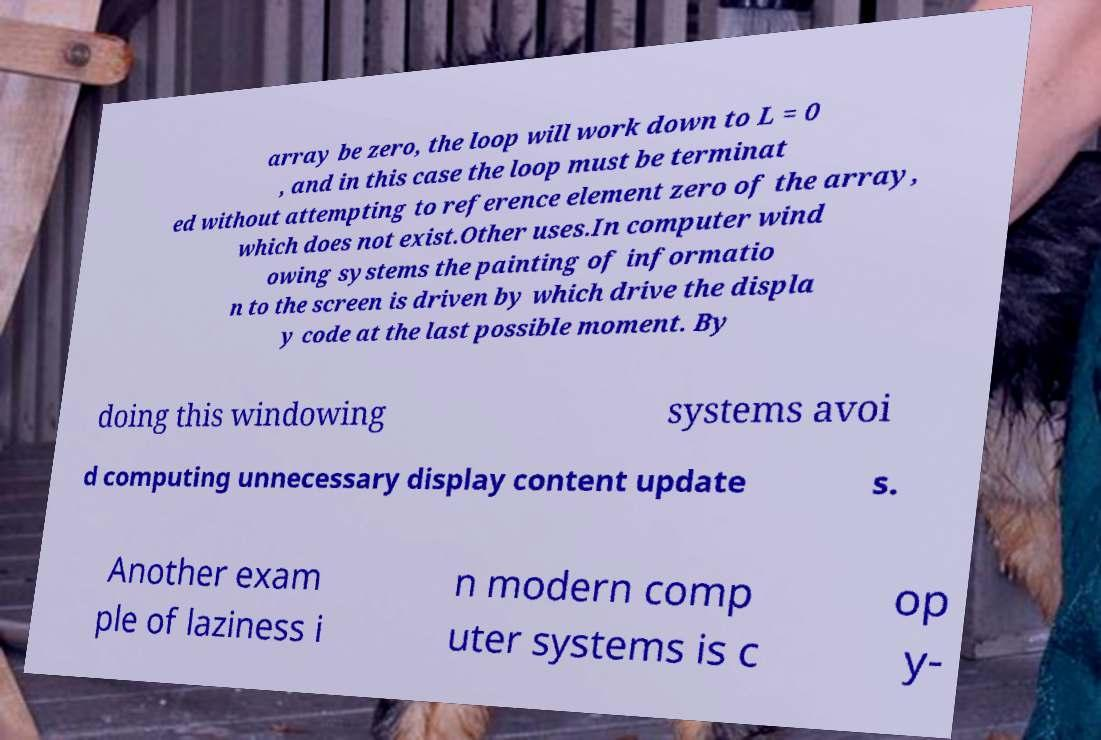I need the written content from this picture converted into text. Can you do that? array be zero, the loop will work down to L = 0 , and in this case the loop must be terminat ed without attempting to reference element zero of the array, which does not exist.Other uses.In computer wind owing systems the painting of informatio n to the screen is driven by which drive the displa y code at the last possible moment. By doing this windowing systems avoi d computing unnecessary display content update s. Another exam ple of laziness i n modern comp uter systems is c op y- 